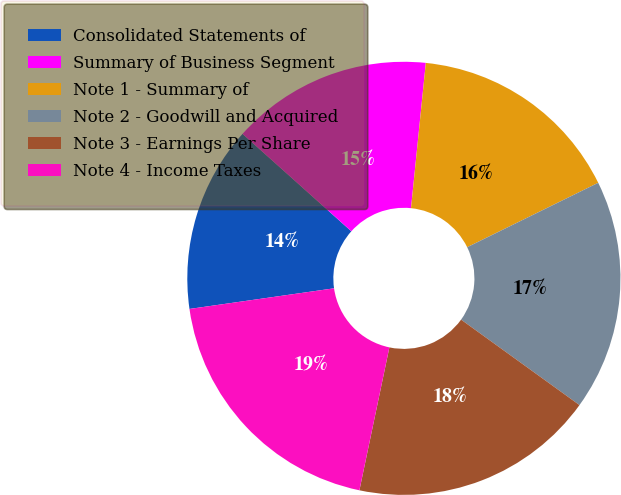Convert chart. <chart><loc_0><loc_0><loc_500><loc_500><pie_chart><fcel>Consolidated Statements of<fcel>Summary of Business Segment<fcel>Note 1 - Summary of<fcel>Note 2 - Goodwill and Acquired<fcel>Note 3 - Earnings Per Share<fcel>Note 4 - Income Taxes<nl><fcel>13.88%<fcel>14.99%<fcel>16.11%<fcel>17.22%<fcel>18.34%<fcel>19.45%<nl></chart> 